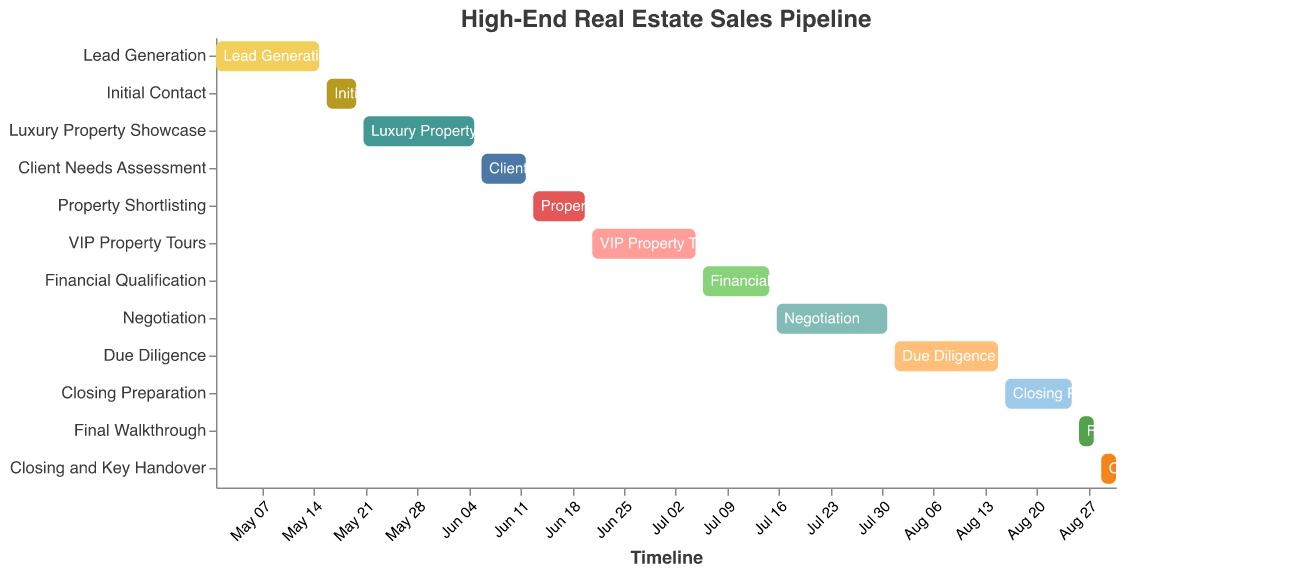What's the title of this chart? The title of the chart is prominently displayed at the top, which is standard in most figures. It reads "High-End Real Estate Sales Pipeline".
Answer: High-End Real Estate Sales Pipeline What is the starting date for the Financial Qualification stage? The Gantt chart uses the horizontal axis to represent the timeline, with specific stages labeled along the y-axis. The Financial Qualification stage starts at 2023-07-06 according to the figure.
Answer: 2023-07-06 Which stage has the longest duration, and how long does it last? The stage lengths can be determined by the distance between the start and end dates for each stage. The VIP Property Tours stage, running from 2023-06-21 to 2023-07-05, spans 15 days, which is the longest duration among all stages.
Answer: VIP Property Tours, 15 days Which stage immediately follows Initial Contact? The order of stages is presented along the y-axis, with each subsequent stage starting after the previous one ends. After Initial Contact, the next stage is Luxury Property Showcase.
Answer: Luxury Property Showcase How many tasks or stages are there in total? By counting the individual task labels listed along the y-axis in the Gantt chart, we can determine that there are 12 stages in total.
Answer: 12 In which month does the Negotiation stage start, and when does it end? The horizontal axis represents a timeline, with dates formatted to show months and days. The Negotiation stage starts on 2023-07-16 and ends on 2023-07-31, both in July.
Answer: July, from 2023-07-16 to 2023-07-31 Compare the duration of Initial Contact and Final Walkthrough stages. Which is longer? Checking their start and end dates: Initial Contact is from 2023-05-16 to 2023-05-20, lasting 5 days, while Final Walkthrough is from 2023-08-26 to 2023-08-28, lasting 3 days. Initial Contact is longer.
Answer: Initial Contact, 5 days What's the total duration from the start of Lead Generation to the end of Closing and Key Handover? Lead Generation starts on 2023-05-01 and Closing and Key Handover ends on 2023-08-31. The total duration from start to end is the difference between these two dates, which is 123 days.
Answer: 123 days Which tasks overlap with the VIP Property Tours stage? To determine overlaps, check the dates of each task against the VIP Property Tours dates (2023-06-21 to 2023-07-05). Property Shortlisting and Financial Qualification stages overlap with VIP Property Tours.
Answer: Property Shortlisting, Financial Qualification What is the median duration of the stages? First, list the durations: 15, 5, 16, 7, 8, 15, 10, 16, 15, 10, 3, 3 (days). Sorting these, we have 3, 3, 5, 7, 8, 10, 10, 15, 15, 15, 16, 16. The median value, being the average of the 6th and 7th elements, is (10+10)/2 = 10 days.
Answer: 10 days 